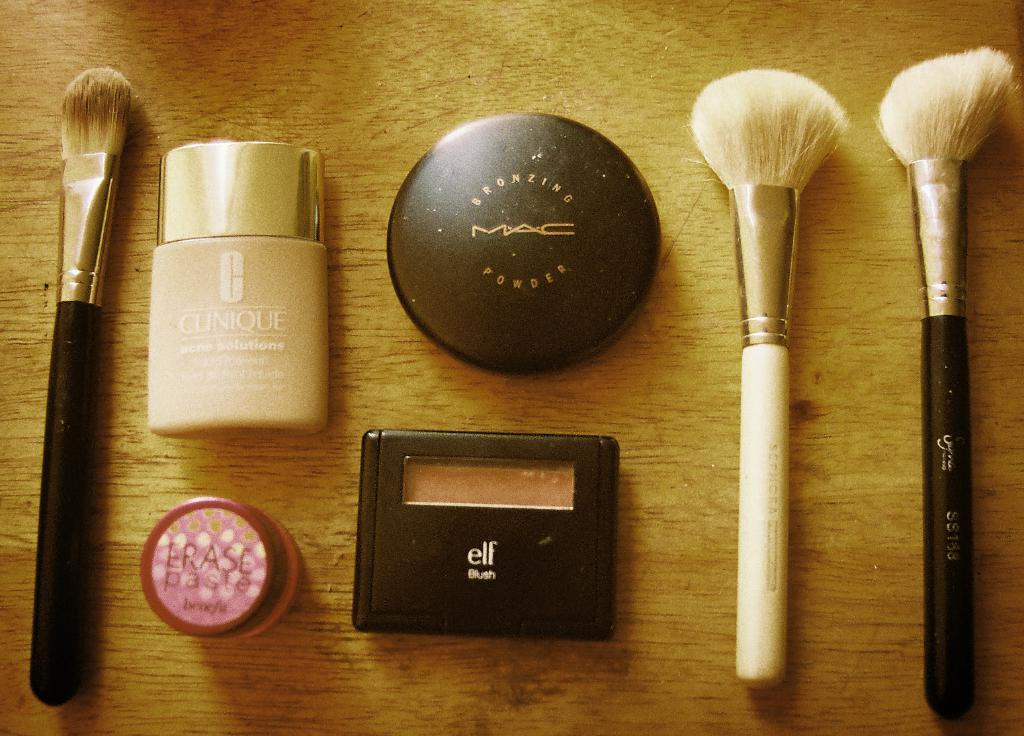What type of tools are visible in the image? There are brushes in the image. What are the brushes used for? The brushes are likely used for applying makeup, as there are makeup objects in the image as well. Where are the brushes and makeup objects located? They are on a wooden platform. What type of seeds are being planted on the wooden platform in the image? There are no seeds or planting activity depicted in the image; it features brushes and makeup objects on a wooden platform. What religious symbols can be seen in the image? There are no religious symbols present in the image. 